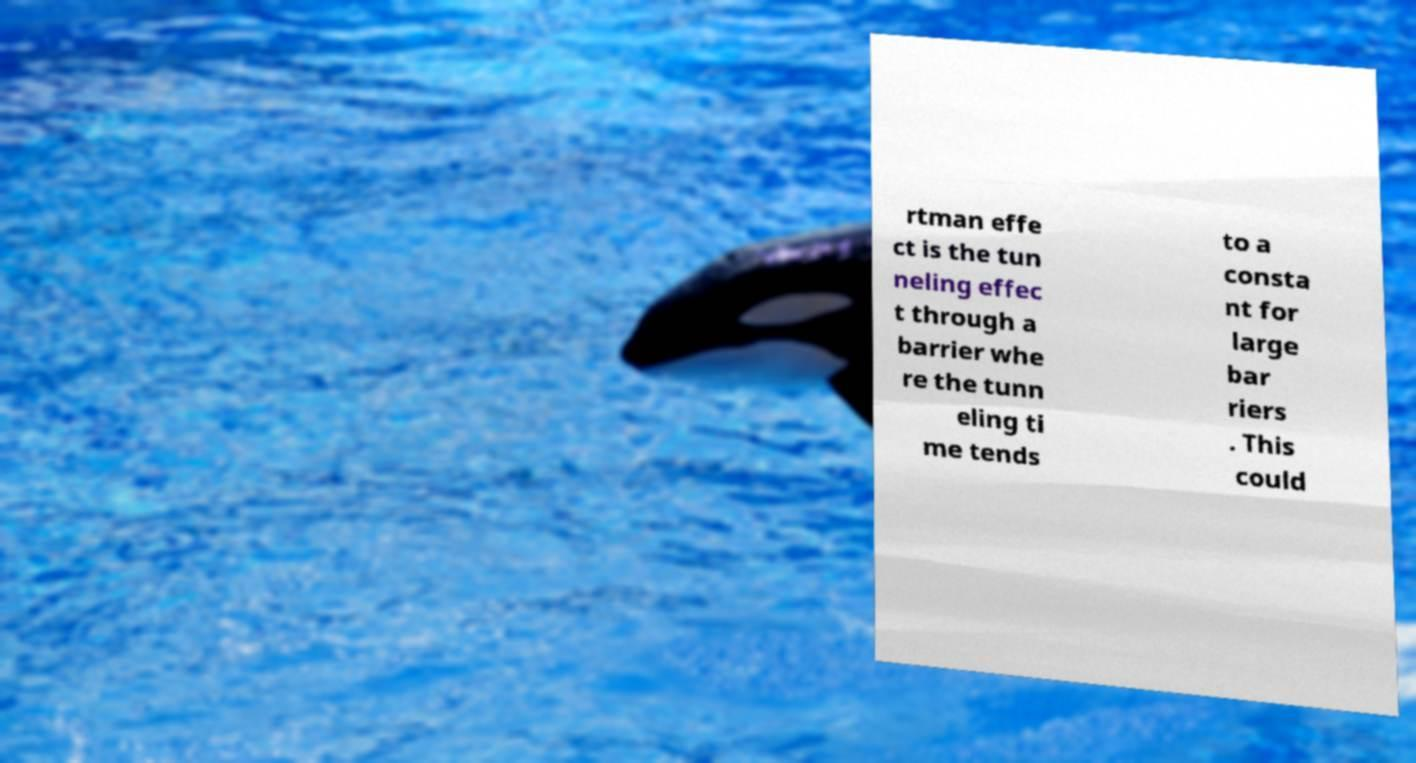Could you assist in decoding the text presented in this image and type it out clearly? rtman effe ct is the tun neling effec t through a barrier whe re the tunn eling ti me tends to a consta nt for large bar riers . This could 